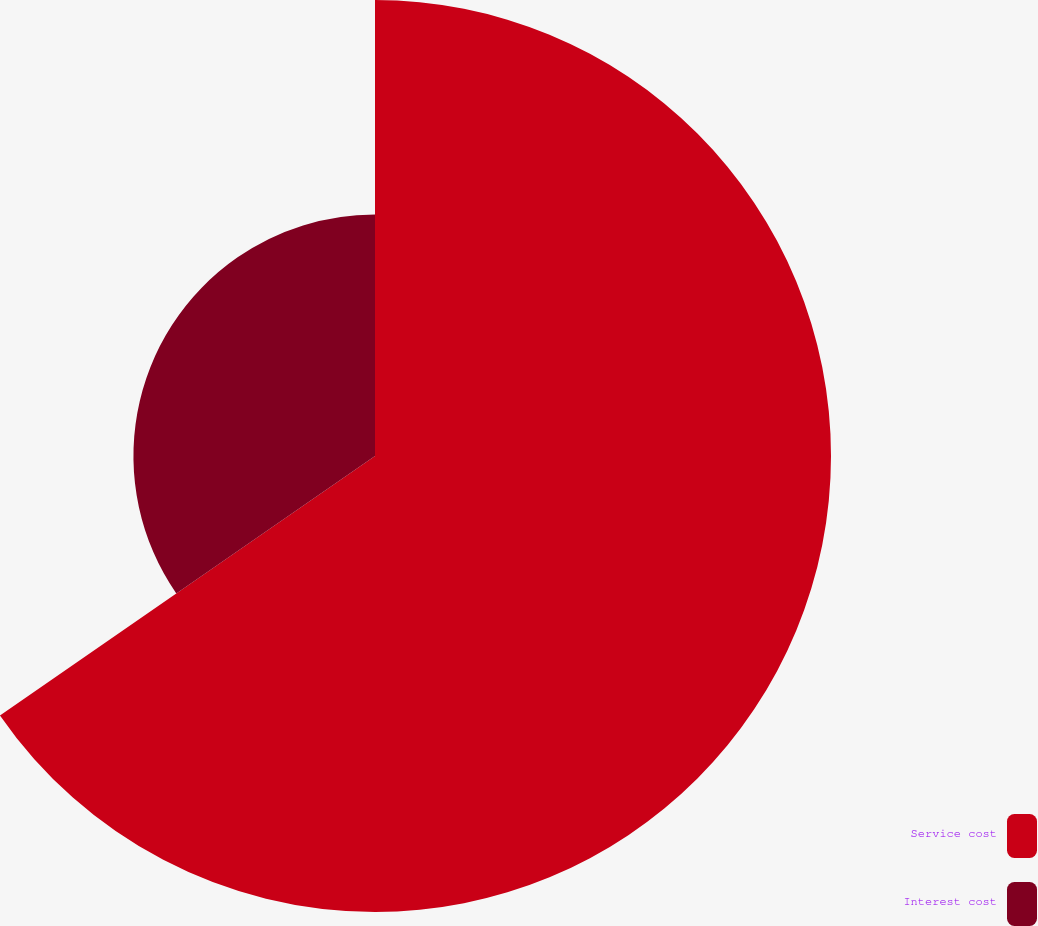Convert chart to OTSL. <chart><loc_0><loc_0><loc_500><loc_500><pie_chart><fcel>Service cost<fcel>Interest cost<nl><fcel>65.37%<fcel>34.63%<nl></chart> 